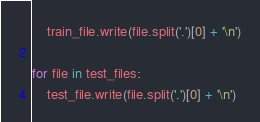<code> <loc_0><loc_0><loc_500><loc_500><_Python_>    train_file.write(file.split('.')[0] + '\n')

for file in test_files:
    test_file.write(file.split('.')[0] + '\n')
</code> 